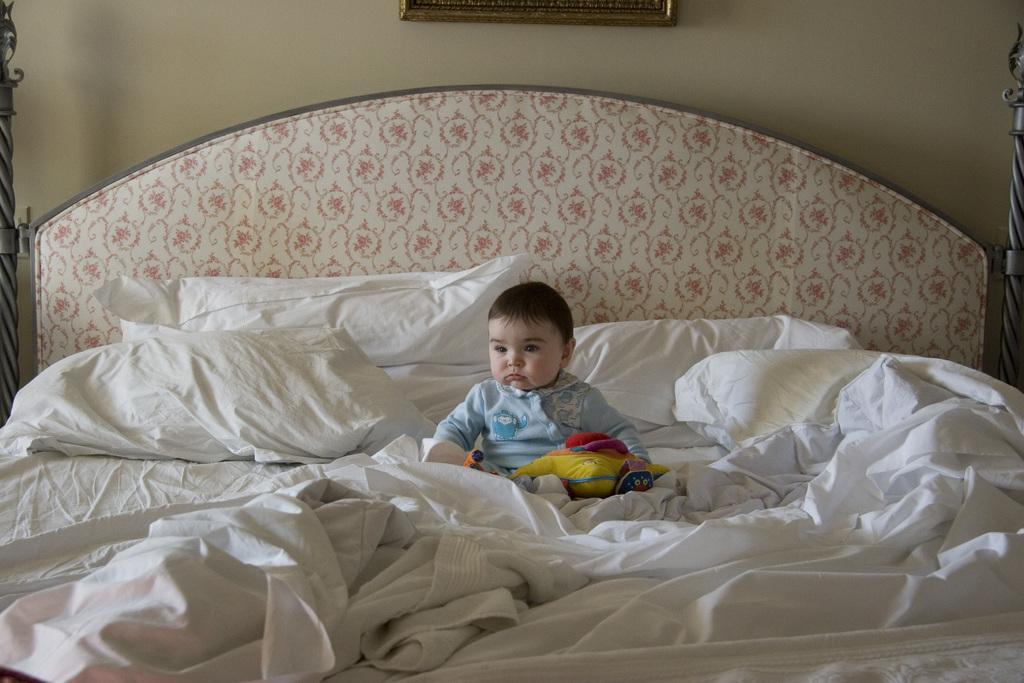Describe this image in one or two sentences. A baby is sitting on the bed behind him there are pillows and wall. 